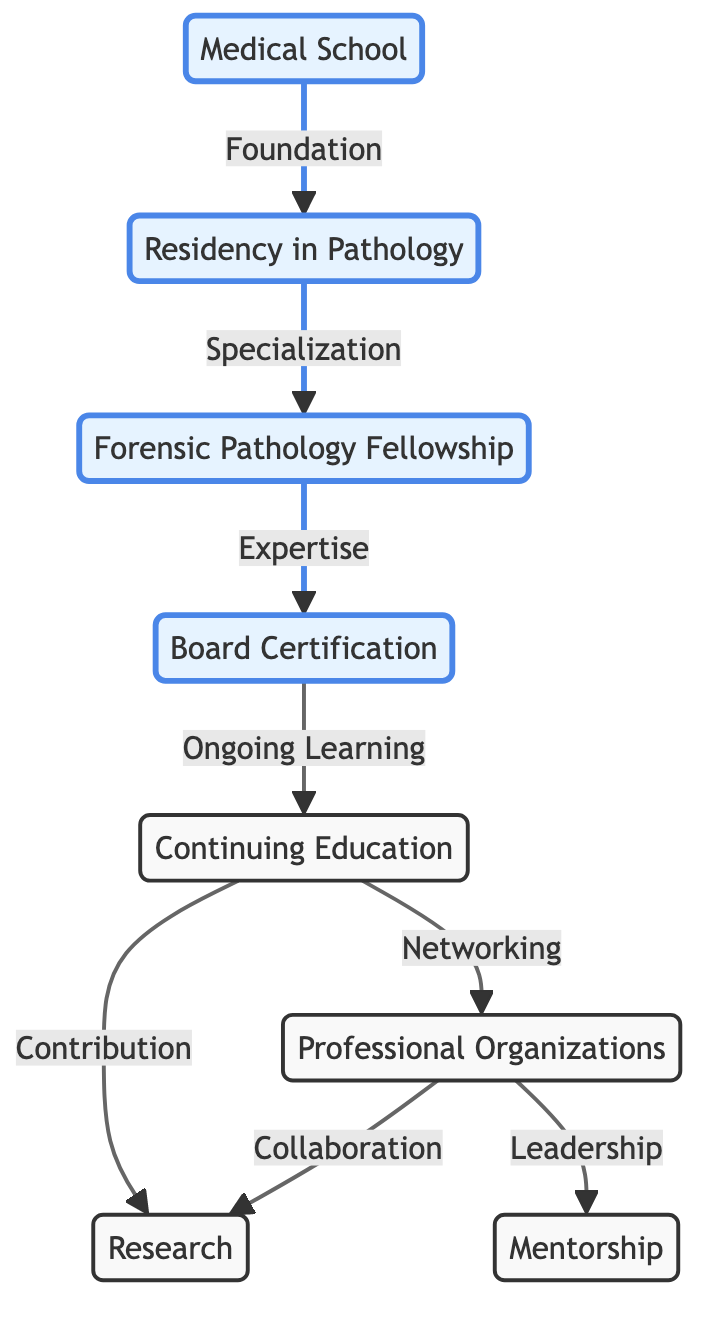What is the first step in a forensic pathologist's career development? The first step in a forensic pathologist's career development is attending Medical School, which provides the foundational knowledge necessary to advance in the field.
Answer: Medical School How many nodes are present in the diagram? The diagram contains a total of eight nodes, each representing different stages or elements in the career development of forensic pathologists.
Answer: 8 What does the arrow from Residency to Fellowship represent? The arrow from Residency to Fellowship signifies the transition from specialized training in pathology to further specialized training specifically in forensic pathology.
Answer: Specialization Which two nodes are connected to Continuing Education? Continuing Education is connected to both Research and Professional Organizations, indicating that ongoing education involves contributions to research and networking through professional organizations.
Answer: Research, Professional Organizations What certification comes after completing the Forensic Pathology Fellowship? After completing the Forensic Pathology Fellowship, the next step is obtaining Board Certification, which verifies the pathologist's expertise in forensic pathology.
Answer: Board Certification What is one role of Professional Organizations in a forensic pathologist's career? Professional Organizations play roles in networking and collaboration, connecting pathologists with opportunities for research and leadership through mentorship.
Answer: Collaboration Which two nodes show a relationship indicating ongoing contributions or activities? Continuing Education and Professional Organizations have relationships indicating ongoing contributions to research and the opportunity for leadership through mentorship, reflecting how these activities interact in a forensic pathologist's career.
Answer: Research, Mentorship How does Continuing Education influence Research? Continuing Education influences Research by providing courses and seminars that help forensic pathologists stay updated and thus contribute effectively to peer-reviewed forensic journals.
Answer: Contribution 